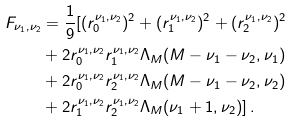<formula> <loc_0><loc_0><loc_500><loc_500>F _ { \nu _ { 1 } , \nu _ { 2 } } & = \frac { 1 } { 9 } [ ( r _ { 0 } ^ { \nu _ { 1 } , \nu _ { 2 } } ) ^ { 2 } + ( r _ { 1 } ^ { \nu _ { 1 } , \nu _ { 2 } } ) ^ { 2 } + ( r _ { 2 } ^ { \nu _ { 1 } , \nu _ { 2 } } ) ^ { 2 } \\ & + 2 r _ { 0 } ^ { \nu _ { 1 } , \nu _ { 2 } } r _ { 1 } ^ { \nu _ { 1 } , \nu _ { 2 } } \Lambda _ { M } ( M - \nu _ { 1 } - \nu _ { 2 } , \nu _ { 1 } ) \\ & + 2 r _ { 0 } ^ { \nu _ { 1 } , \nu _ { 2 } } r _ { 2 } ^ { \nu _ { 1 } , \nu _ { 2 } } \Lambda _ { M } ( M - \nu _ { 1 } - \nu _ { 2 } , \nu _ { 2 } ) \\ & + 2 r _ { 1 } ^ { \nu _ { 1 } , \nu _ { 2 } } r _ { 2 } ^ { \nu _ { 1 } , \nu _ { 2 } } \Lambda _ { M } ( \nu _ { 1 } + 1 , \nu _ { 2 } ) ] \, .</formula> 